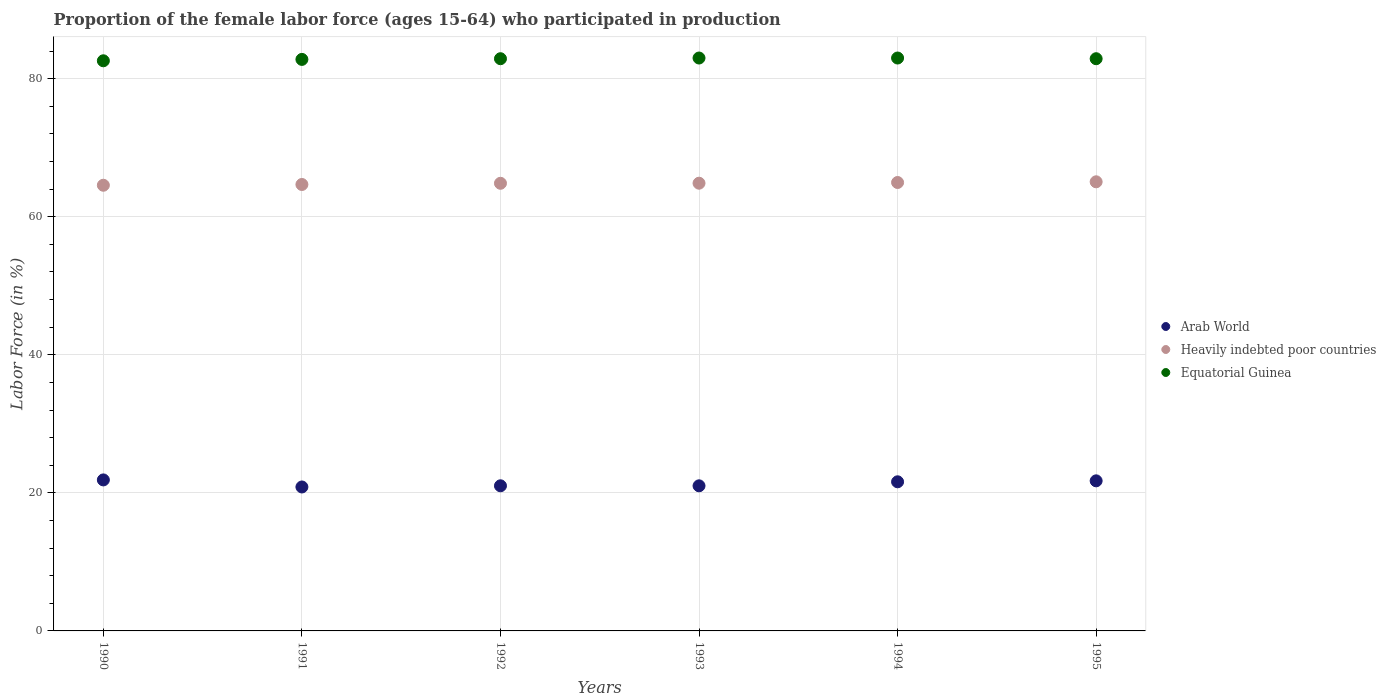How many different coloured dotlines are there?
Ensure brevity in your answer.  3. What is the proportion of the female labor force who participated in production in Arab World in 1994?
Offer a very short reply. 21.6. Across all years, what is the maximum proportion of the female labor force who participated in production in Heavily indebted poor countries?
Make the answer very short. 65.07. Across all years, what is the minimum proportion of the female labor force who participated in production in Heavily indebted poor countries?
Provide a succinct answer. 64.57. In which year was the proportion of the female labor force who participated in production in Equatorial Guinea maximum?
Your response must be concise. 1993. In which year was the proportion of the female labor force who participated in production in Equatorial Guinea minimum?
Offer a terse response. 1990. What is the total proportion of the female labor force who participated in production in Equatorial Guinea in the graph?
Provide a succinct answer. 497.2. What is the difference between the proportion of the female labor force who participated in production in Arab World in 1990 and that in 1992?
Offer a very short reply. 0.85. What is the difference between the proportion of the female labor force who participated in production in Arab World in 1992 and the proportion of the female labor force who participated in production in Heavily indebted poor countries in 1990?
Your response must be concise. -43.54. What is the average proportion of the female labor force who participated in production in Equatorial Guinea per year?
Your response must be concise. 82.87. In the year 1995, what is the difference between the proportion of the female labor force who participated in production in Arab World and proportion of the female labor force who participated in production in Equatorial Guinea?
Offer a very short reply. -61.16. What is the ratio of the proportion of the female labor force who participated in production in Heavily indebted poor countries in 1992 to that in 1995?
Make the answer very short. 1. What is the difference between the highest and the second highest proportion of the female labor force who participated in production in Heavily indebted poor countries?
Give a very brief answer. 0.1. What is the difference between the highest and the lowest proportion of the female labor force who participated in production in Arab World?
Provide a short and direct response. 1.02. Does the proportion of the female labor force who participated in production in Arab World monotonically increase over the years?
Keep it short and to the point. No. What is the difference between two consecutive major ticks on the Y-axis?
Give a very brief answer. 20. Where does the legend appear in the graph?
Ensure brevity in your answer.  Center right. How are the legend labels stacked?
Your response must be concise. Vertical. What is the title of the graph?
Your answer should be very brief. Proportion of the female labor force (ages 15-64) who participated in production. What is the label or title of the Y-axis?
Ensure brevity in your answer.  Labor Force (in %). What is the Labor Force (in %) of Arab World in 1990?
Make the answer very short. 21.88. What is the Labor Force (in %) in Heavily indebted poor countries in 1990?
Offer a terse response. 64.57. What is the Labor Force (in %) in Equatorial Guinea in 1990?
Make the answer very short. 82.6. What is the Labor Force (in %) in Arab World in 1991?
Your answer should be very brief. 20.85. What is the Labor Force (in %) of Heavily indebted poor countries in 1991?
Your answer should be compact. 64.68. What is the Labor Force (in %) of Equatorial Guinea in 1991?
Your response must be concise. 82.8. What is the Labor Force (in %) of Arab World in 1992?
Provide a succinct answer. 21.02. What is the Labor Force (in %) of Heavily indebted poor countries in 1992?
Offer a terse response. 64.85. What is the Labor Force (in %) in Equatorial Guinea in 1992?
Make the answer very short. 82.9. What is the Labor Force (in %) in Arab World in 1993?
Offer a terse response. 21.02. What is the Labor Force (in %) of Heavily indebted poor countries in 1993?
Your answer should be very brief. 64.86. What is the Labor Force (in %) of Arab World in 1994?
Your answer should be compact. 21.6. What is the Labor Force (in %) in Heavily indebted poor countries in 1994?
Provide a succinct answer. 64.97. What is the Labor Force (in %) in Arab World in 1995?
Make the answer very short. 21.74. What is the Labor Force (in %) in Heavily indebted poor countries in 1995?
Provide a succinct answer. 65.07. What is the Labor Force (in %) in Equatorial Guinea in 1995?
Keep it short and to the point. 82.9. Across all years, what is the maximum Labor Force (in %) in Arab World?
Offer a terse response. 21.88. Across all years, what is the maximum Labor Force (in %) in Heavily indebted poor countries?
Offer a very short reply. 65.07. Across all years, what is the maximum Labor Force (in %) of Equatorial Guinea?
Provide a succinct answer. 83. Across all years, what is the minimum Labor Force (in %) of Arab World?
Ensure brevity in your answer.  20.85. Across all years, what is the minimum Labor Force (in %) of Heavily indebted poor countries?
Offer a terse response. 64.57. Across all years, what is the minimum Labor Force (in %) of Equatorial Guinea?
Make the answer very short. 82.6. What is the total Labor Force (in %) in Arab World in the graph?
Provide a succinct answer. 128.13. What is the total Labor Force (in %) of Heavily indebted poor countries in the graph?
Make the answer very short. 389. What is the total Labor Force (in %) of Equatorial Guinea in the graph?
Keep it short and to the point. 497.2. What is the difference between the Labor Force (in %) of Arab World in 1990 and that in 1991?
Provide a succinct answer. 1.02. What is the difference between the Labor Force (in %) of Heavily indebted poor countries in 1990 and that in 1991?
Offer a terse response. -0.11. What is the difference between the Labor Force (in %) in Equatorial Guinea in 1990 and that in 1991?
Provide a short and direct response. -0.2. What is the difference between the Labor Force (in %) of Arab World in 1990 and that in 1992?
Keep it short and to the point. 0.85. What is the difference between the Labor Force (in %) of Heavily indebted poor countries in 1990 and that in 1992?
Offer a terse response. -0.28. What is the difference between the Labor Force (in %) in Arab World in 1990 and that in 1993?
Ensure brevity in your answer.  0.86. What is the difference between the Labor Force (in %) in Heavily indebted poor countries in 1990 and that in 1993?
Offer a terse response. -0.3. What is the difference between the Labor Force (in %) of Equatorial Guinea in 1990 and that in 1993?
Offer a terse response. -0.4. What is the difference between the Labor Force (in %) of Arab World in 1990 and that in 1994?
Keep it short and to the point. 0.27. What is the difference between the Labor Force (in %) of Heavily indebted poor countries in 1990 and that in 1994?
Your answer should be compact. -0.4. What is the difference between the Labor Force (in %) of Equatorial Guinea in 1990 and that in 1994?
Make the answer very short. -0.4. What is the difference between the Labor Force (in %) of Arab World in 1990 and that in 1995?
Keep it short and to the point. 0.13. What is the difference between the Labor Force (in %) in Heavily indebted poor countries in 1990 and that in 1995?
Keep it short and to the point. -0.5. What is the difference between the Labor Force (in %) of Arab World in 1991 and that in 1992?
Provide a succinct answer. -0.17. What is the difference between the Labor Force (in %) of Heavily indebted poor countries in 1991 and that in 1992?
Ensure brevity in your answer.  -0.18. What is the difference between the Labor Force (in %) in Equatorial Guinea in 1991 and that in 1992?
Ensure brevity in your answer.  -0.1. What is the difference between the Labor Force (in %) in Arab World in 1991 and that in 1993?
Offer a terse response. -0.17. What is the difference between the Labor Force (in %) in Heavily indebted poor countries in 1991 and that in 1993?
Offer a terse response. -0.19. What is the difference between the Labor Force (in %) of Arab World in 1991 and that in 1994?
Offer a very short reply. -0.75. What is the difference between the Labor Force (in %) in Heavily indebted poor countries in 1991 and that in 1994?
Offer a terse response. -0.29. What is the difference between the Labor Force (in %) in Arab World in 1991 and that in 1995?
Your answer should be compact. -0.89. What is the difference between the Labor Force (in %) of Heavily indebted poor countries in 1991 and that in 1995?
Your answer should be compact. -0.39. What is the difference between the Labor Force (in %) in Equatorial Guinea in 1991 and that in 1995?
Provide a succinct answer. -0.1. What is the difference between the Labor Force (in %) in Arab World in 1992 and that in 1993?
Give a very brief answer. 0. What is the difference between the Labor Force (in %) of Heavily indebted poor countries in 1992 and that in 1993?
Offer a very short reply. -0.01. What is the difference between the Labor Force (in %) in Arab World in 1992 and that in 1994?
Offer a terse response. -0.58. What is the difference between the Labor Force (in %) of Heavily indebted poor countries in 1992 and that in 1994?
Provide a succinct answer. -0.11. What is the difference between the Labor Force (in %) of Equatorial Guinea in 1992 and that in 1994?
Offer a terse response. -0.1. What is the difference between the Labor Force (in %) in Arab World in 1992 and that in 1995?
Make the answer very short. -0.72. What is the difference between the Labor Force (in %) in Heavily indebted poor countries in 1992 and that in 1995?
Your answer should be very brief. -0.21. What is the difference between the Labor Force (in %) in Equatorial Guinea in 1992 and that in 1995?
Your response must be concise. 0. What is the difference between the Labor Force (in %) in Arab World in 1993 and that in 1994?
Your answer should be compact. -0.58. What is the difference between the Labor Force (in %) in Heavily indebted poor countries in 1993 and that in 1994?
Give a very brief answer. -0.1. What is the difference between the Labor Force (in %) of Equatorial Guinea in 1993 and that in 1994?
Make the answer very short. 0. What is the difference between the Labor Force (in %) in Arab World in 1993 and that in 1995?
Offer a terse response. -0.72. What is the difference between the Labor Force (in %) in Heavily indebted poor countries in 1993 and that in 1995?
Keep it short and to the point. -0.2. What is the difference between the Labor Force (in %) of Arab World in 1994 and that in 1995?
Ensure brevity in your answer.  -0.14. What is the difference between the Labor Force (in %) in Heavily indebted poor countries in 1994 and that in 1995?
Ensure brevity in your answer.  -0.1. What is the difference between the Labor Force (in %) in Equatorial Guinea in 1994 and that in 1995?
Offer a very short reply. 0.1. What is the difference between the Labor Force (in %) in Arab World in 1990 and the Labor Force (in %) in Heavily indebted poor countries in 1991?
Provide a succinct answer. -42.8. What is the difference between the Labor Force (in %) of Arab World in 1990 and the Labor Force (in %) of Equatorial Guinea in 1991?
Provide a succinct answer. -60.92. What is the difference between the Labor Force (in %) in Heavily indebted poor countries in 1990 and the Labor Force (in %) in Equatorial Guinea in 1991?
Your answer should be very brief. -18.23. What is the difference between the Labor Force (in %) of Arab World in 1990 and the Labor Force (in %) of Heavily indebted poor countries in 1992?
Give a very brief answer. -42.98. What is the difference between the Labor Force (in %) of Arab World in 1990 and the Labor Force (in %) of Equatorial Guinea in 1992?
Offer a very short reply. -61.02. What is the difference between the Labor Force (in %) in Heavily indebted poor countries in 1990 and the Labor Force (in %) in Equatorial Guinea in 1992?
Your answer should be very brief. -18.33. What is the difference between the Labor Force (in %) in Arab World in 1990 and the Labor Force (in %) in Heavily indebted poor countries in 1993?
Offer a very short reply. -42.99. What is the difference between the Labor Force (in %) in Arab World in 1990 and the Labor Force (in %) in Equatorial Guinea in 1993?
Ensure brevity in your answer.  -61.12. What is the difference between the Labor Force (in %) in Heavily indebted poor countries in 1990 and the Labor Force (in %) in Equatorial Guinea in 1993?
Your answer should be compact. -18.43. What is the difference between the Labor Force (in %) in Arab World in 1990 and the Labor Force (in %) in Heavily indebted poor countries in 1994?
Offer a very short reply. -43.09. What is the difference between the Labor Force (in %) of Arab World in 1990 and the Labor Force (in %) of Equatorial Guinea in 1994?
Your answer should be very brief. -61.12. What is the difference between the Labor Force (in %) of Heavily indebted poor countries in 1990 and the Labor Force (in %) of Equatorial Guinea in 1994?
Provide a succinct answer. -18.43. What is the difference between the Labor Force (in %) in Arab World in 1990 and the Labor Force (in %) in Heavily indebted poor countries in 1995?
Give a very brief answer. -43.19. What is the difference between the Labor Force (in %) of Arab World in 1990 and the Labor Force (in %) of Equatorial Guinea in 1995?
Provide a short and direct response. -61.02. What is the difference between the Labor Force (in %) of Heavily indebted poor countries in 1990 and the Labor Force (in %) of Equatorial Guinea in 1995?
Make the answer very short. -18.33. What is the difference between the Labor Force (in %) in Arab World in 1991 and the Labor Force (in %) in Heavily indebted poor countries in 1992?
Keep it short and to the point. -44. What is the difference between the Labor Force (in %) of Arab World in 1991 and the Labor Force (in %) of Equatorial Guinea in 1992?
Keep it short and to the point. -62.05. What is the difference between the Labor Force (in %) of Heavily indebted poor countries in 1991 and the Labor Force (in %) of Equatorial Guinea in 1992?
Offer a terse response. -18.22. What is the difference between the Labor Force (in %) in Arab World in 1991 and the Labor Force (in %) in Heavily indebted poor countries in 1993?
Offer a terse response. -44.01. What is the difference between the Labor Force (in %) in Arab World in 1991 and the Labor Force (in %) in Equatorial Guinea in 1993?
Provide a short and direct response. -62.15. What is the difference between the Labor Force (in %) of Heavily indebted poor countries in 1991 and the Labor Force (in %) of Equatorial Guinea in 1993?
Offer a terse response. -18.32. What is the difference between the Labor Force (in %) of Arab World in 1991 and the Labor Force (in %) of Heavily indebted poor countries in 1994?
Offer a very short reply. -44.11. What is the difference between the Labor Force (in %) of Arab World in 1991 and the Labor Force (in %) of Equatorial Guinea in 1994?
Offer a terse response. -62.15. What is the difference between the Labor Force (in %) of Heavily indebted poor countries in 1991 and the Labor Force (in %) of Equatorial Guinea in 1994?
Provide a short and direct response. -18.32. What is the difference between the Labor Force (in %) of Arab World in 1991 and the Labor Force (in %) of Heavily indebted poor countries in 1995?
Offer a very short reply. -44.21. What is the difference between the Labor Force (in %) in Arab World in 1991 and the Labor Force (in %) in Equatorial Guinea in 1995?
Your response must be concise. -62.05. What is the difference between the Labor Force (in %) in Heavily indebted poor countries in 1991 and the Labor Force (in %) in Equatorial Guinea in 1995?
Your answer should be compact. -18.22. What is the difference between the Labor Force (in %) of Arab World in 1992 and the Labor Force (in %) of Heavily indebted poor countries in 1993?
Keep it short and to the point. -43.84. What is the difference between the Labor Force (in %) in Arab World in 1992 and the Labor Force (in %) in Equatorial Guinea in 1993?
Ensure brevity in your answer.  -61.98. What is the difference between the Labor Force (in %) in Heavily indebted poor countries in 1992 and the Labor Force (in %) in Equatorial Guinea in 1993?
Ensure brevity in your answer.  -18.15. What is the difference between the Labor Force (in %) of Arab World in 1992 and the Labor Force (in %) of Heavily indebted poor countries in 1994?
Keep it short and to the point. -43.94. What is the difference between the Labor Force (in %) in Arab World in 1992 and the Labor Force (in %) in Equatorial Guinea in 1994?
Your answer should be compact. -61.98. What is the difference between the Labor Force (in %) of Heavily indebted poor countries in 1992 and the Labor Force (in %) of Equatorial Guinea in 1994?
Your answer should be compact. -18.15. What is the difference between the Labor Force (in %) of Arab World in 1992 and the Labor Force (in %) of Heavily indebted poor countries in 1995?
Offer a terse response. -44.04. What is the difference between the Labor Force (in %) of Arab World in 1992 and the Labor Force (in %) of Equatorial Guinea in 1995?
Ensure brevity in your answer.  -61.88. What is the difference between the Labor Force (in %) in Heavily indebted poor countries in 1992 and the Labor Force (in %) in Equatorial Guinea in 1995?
Ensure brevity in your answer.  -18.05. What is the difference between the Labor Force (in %) of Arab World in 1993 and the Labor Force (in %) of Heavily indebted poor countries in 1994?
Make the answer very short. -43.95. What is the difference between the Labor Force (in %) of Arab World in 1993 and the Labor Force (in %) of Equatorial Guinea in 1994?
Give a very brief answer. -61.98. What is the difference between the Labor Force (in %) of Heavily indebted poor countries in 1993 and the Labor Force (in %) of Equatorial Guinea in 1994?
Offer a very short reply. -18.14. What is the difference between the Labor Force (in %) in Arab World in 1993 and the Labor Force (in %) in Heavily indebted poor countries in 1995?
Offer a very short reply. -44.05. What is the difference between the Labor Force (in %) in Arab World in 1993 and the Labor Force (in %) in Equatorial Guinea in 1995?
Keep it short and to the point. -61.88. What is the difference between the Labor Force (in %) in Heavily indebted poor countries in 1993 and the Labor Force (in %) in Equatorial Guinea in 1995?
Make the answer very short. -18.04. What is the difference between the Labor Force (in %) in Arab World in 1994 and the Labor Force (in %) in Heavily indebted poor countries in 1995?
Offer a terse response. -43.46. What is the difference between the Labor Force (in %) in Arab World in 1994 and the Labor Force (in %) in Equatorial Guinea in 1995?
Provide a short and direct response. -61.3. What is the difference between the Labor Force (in %) of Heavily indebted poor countries in 1994 and the Labor Force (in %) of Equatorial Guinea in 1995?
Offer a terse response. -17.93. What is the average Labor Force (in %) in Arab World per year?
Offer a terse response. 21.35. What is the average Labor Force (in %) in Heavily indebted poor countries per year?
Keep it short and to the point. 64.83. What is the average Labor Force (in %) of Equatorial Guinea per year?
Give a very brief answer. 82.87. In the year 1990, what is the difference between the Labor Force (in %) in Arab World and Labor Force (in %) in Heavily indebted poor countries?
Give a very brief answer. -42.69. In the year 1990, what is the difference between the Labor Force (in %) in Arab World and Labor Force (in %) in Equatorial Guinea?
Offer a very short reply. -60.72. In the year 1990, what is the difference between the Labor Force (in %) in Heavily indebted poor countries and Labor Force (in %) in Equatorial Guinea?
Your answer should be compact. -18.03. In the year 1991, what is the difference between the Labor Force (in %) in Arab World and Labor Force (in %) in Heavily indebted poor countries?
Your answer should be compact. -43.82. In the year 1991, what is the difference between the Labor Force (in %) in Arab World and Labor Force (in %) in Equatorial Guinea?
Ensure brevity in your answer.  -61.95. In the year 1991, what is the difference between the Labor Force (in %) of Heavily indebted poor countries and Labor Force (in %) of Equatorial Guinea?
Your answer should be compact. -18.12. In the year 1992, what is the difference between the Labor Force (in %) of Arab World and Labor Force (in %) of Heavily indebted poor countries?
Your answer should be very brief. -43.83. In the year 1992, what is the difference between the Labor Force (in %) of Arab World and Labor Force (in %) of Equatorial Guinea?
Make the answer very short. -61.88. In the year 1992, what is the difference between the Labor Force (in %) of Heavily indebted poor countries and Labor Force (in %) of Equatorial Guinea?
Offer a very short reply. -18.05. In the year 1993, what is the difference between the Labor Force (in %) of Arab World and Labor Force (in %) of Heavily indebted poor countries?
Offer a terse response. -43.84. In the year 1993, what is the difference between the Labor Force (in %) of Arab World and Labor Force (in %) of Equatorial Guinea?
Provide a short and direct response. -61.98. In the year 1993, what is the difference between the Labor Force (in %) in Heavily indebted poor countries and Labor Force (in %) in Equatorial Guinea?
Offer a very short reply. -18.14. In the year 1994, what is the difference between the Labor Force (in %) of Arab World and Labor Force (in %) of Heavily indebted poor countries?
Your answer should be compact. -43.36. In the year 1994, what is the difference between the Labor Force (in %) of Arab World and Labor Force (in %) of Equatorial Guinea?
Provide a succinct answer. -61.4. In the year 1994, what is the difference between the Labor Force (in %) of Heavily indebted poor countries and Labor Force (in %) of Equatorial Guinea?
Ensure brevity in your answer.  -18.03. In the year 1995, what is the difference between the Labor Force (in %) of Arab World and Labor Force (in %) of Heavily indebted poor countries?
Offer a terse response. -43.32. In the year 1995, what is the difference between the Labor Force (in %) in Arab World and Labor Force (in %) in Equatorial Guinea?
Keep it short and to the point. -61.16. In the year 1995, what is the difference between the Labor Force (in %) of Heavily indebted poor countries and Labor Force (in %) of Equatorial Guinea?
Offer a terse response. -17.83. What is the ratio of the Labor Force (in %) in Arab World in 1990 to that in 1991?
Your answer should be compact. 1.05. What is the ratio of the Labor Force (in %) of Heavily indebted poor countries in 1990 to that in 1991?
Provide a succinct answer. 1. What is the ratio of the Labor Force (in %) of Arab World in 1990 to that in 1992?
Your response must be concise. 1.04. What is the ratio of the Labor Force (in %) in Equatorial Guinea in 1990 to that in 1992?
Provide a short and direct response. 1. What is the ratio of the Labor Force (in %) in Arab World in 1990 to that in 1993?
Your answer should be very brief. 1.04. What is the ratio of the Labor Force (in %) of Arab World in 1990 to that in 1994?
Make the answer very short. 1.01. What is the ratio of the Labor Force (in %) of Heavily indebted poor countries in 1990 to that in 1995?
Make the answer very short. 0.99. What is the ratio of the Labor Force (in %) of Arab World in 1991 to that in 1992?
Offer a terse response. 0.99. What is the ratio of the Labor Force (in %) of Equatorial Guinea in 1991 to that in 1992?
Your answer should be very brief. 1. What is the ratio of the Labor Force (in %) of Equatorial Guinea in 1991 to that in 1993?
Offer a terse response. 1. What is the ratio of the Labor Force (in %) in Arab World in 1991 to that in 1994?
Offer a very short reply. 0.97. What is the ratio of the Labor Force (in %) of Heavily indebted poor countries in 1991 to that in 1994?
Make the answer very short. 1. What is the ratio of the Labor Force (in %) in Equatorial Guinea in 1991 to that in 1994?
Your answer should be very brief. 1. What is the ratio of the Labor Force (in %) in Arab World in 1991 to that in 1995?
Your answer should be compact. 0.96. What is the ratio of the Labor Force (in %) of Arab World in 1992 to that in 1993?
Give a very brief answer. 1. What is the ratio of the Labor Force (in %) in Heavily indebted poor countries in 1992 to that in 1993?
Provide a short and direct response. 1. What is the ratio of the Labor Force (in %) in Equatorial Guinea in 1992 to that in 1993?
Keep it short and to the point. 1. What is the ratio of the Labor Force (in %) of Arab World in 1992 to that in 1994?
Your answer should be compact. 0.97. What is the ratio of the Labor Force (in %) in Heavily indebted poor countries in 1992 to that in 1994?
Offer a very short reply. 1. What is the ratio of the Labor Force (in %) in Equatorial Guinea in 1992 to that in 1994?
Offer a terse response. 1. What is the ratio of the Labor Force (in %) in Arab World in 1992 to that in 1995?
Keep it short and to the point. 0.97. What is the ratio of the Labor Force (in %) of Equatorial Guinea in 1992 to that in 1995?
Provide a short and direct response. 1. What is the ratio of the Labor Force (in %) of Heavily indebted poor countries in 1993 to that in 1994?
Your answer should be compact. 1. What is the ratio of the Labor Force (in %) of Equatorial Guinea in 1993 to that in 1994?
Provide a succinct answer. 1. What is the ratio of the Labor Force (in %) in Arab World in 1993 to that in 1995?
Offer a very short reply. 0.97. What is the ratio of the Labor Force (in %) in Heavily indebted poor countries in 1993 to that in 1995?
Your answer should be very brief. 1. What is the ratio of the Labor Force (in %) of Arab World in 1994 to that in 1995?
Make the answer very short. 0.99. What is the difference between the highest and the second highest Labor Force (in %) of Arab World?
Offer a very short reply. 0.13. What is the difference between the highest and the second highest Labor Force (in %) in Heavily indebted poor countries?
Keep it short and to the point. 0.1. What is the difference between the highest and the lowest Labor Force (in %) of Arab World?
Give a very brief answer. 1.02. What is the difference between the highest and the lowest Labor Force (in %) in Heavily indebted poor countries?
Give a very brief answer. 0.5. What is the difference between the highest and the lowest Labor Force (in %) in Equatorial Guinea?
Keep it short and to the point. 0.4. 